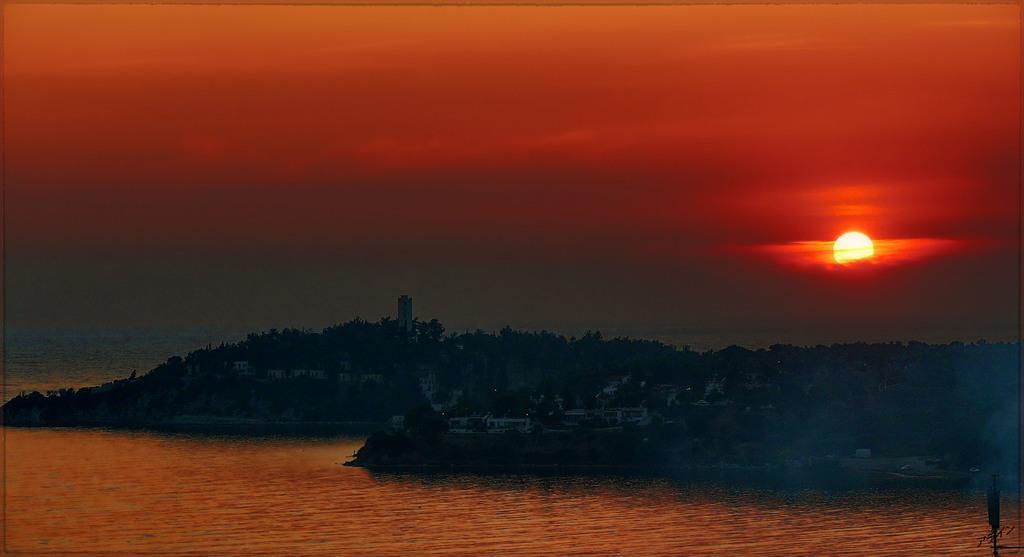In one or two sentences, can you explain what this image depicts? In this image there is the sky truncated towards the top of the image, there is the sun in the sky, there are plants, there are buildings, there is water truncated towards the bottom of the image, there is water truncated towards the left of the image, there is an object truncated towards the bottom of the image. 